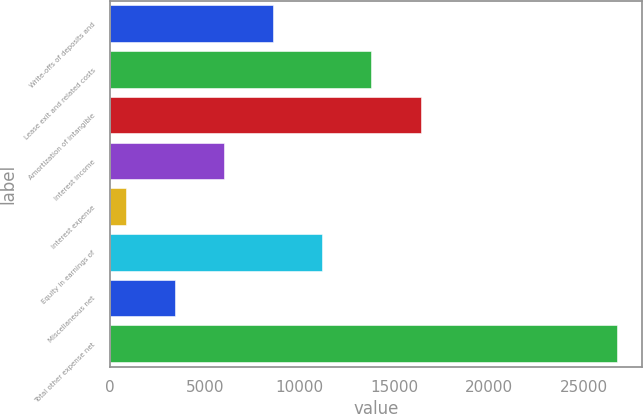<chart> <loc_0><loc_0><loc_500><loc_500><bar_chart><fcel>Write-offs of deposits and<fcel>Lease exit and related costs<fcel>Amortization of intangible<fcel>Interest income<fcel>Interest expense<fcel>Equity in earnings of<fcel>Miscellaneous net<fcel>Total other expense net<nl><fcel>8615.1<fcel>13792.5<fcel>16381.2<fcel>6026.4<fcel>849<fcel>11203.8<fcel>3437.7<fcel>26736<nl></chart> 